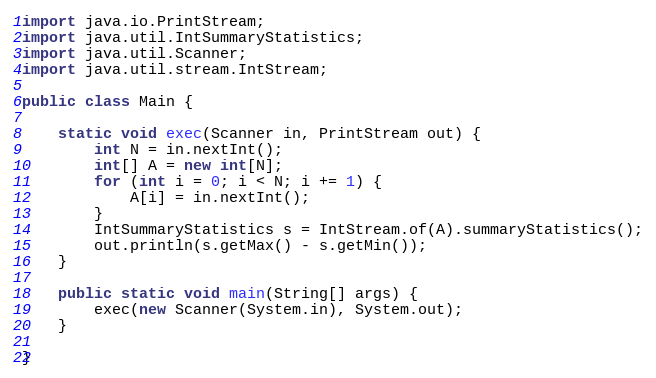Convert code to text. <code><loc_0><loc_0><loc_500><loc_500><_Java_>import java.io.PrintStream;
import java.util.IntSummaryStatistics;
import java.util.Scanner;
import java.util.stream.IntStream;

public class Main {

	static void exec(Scanner in, PrintStream out) {
		int N = in.nextInt();
		int[] A = new int[N];
		for (int i = 0; i < N; i += 1) {
			A[i] = in.nextInt();
		}
		IntSummaryStatistics s = IntStream.of(A).summaryStatistics();
		out.println(s.getMax() - s.getMin());
	}

	public static void main(String[] args) {
		exec(new Scanner(System.in), System.out);
	}

}
</code> 